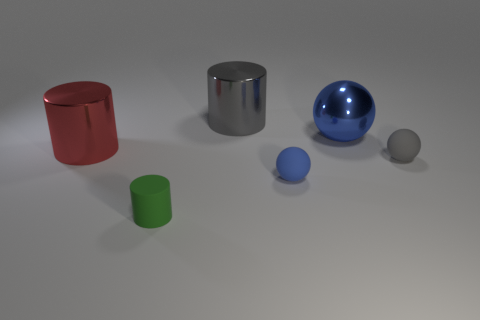Are there any other balls of the same color as the large metallic ball? Yes, there is a smaller ball to the right of the large metallic ball that shares the same blue color. 